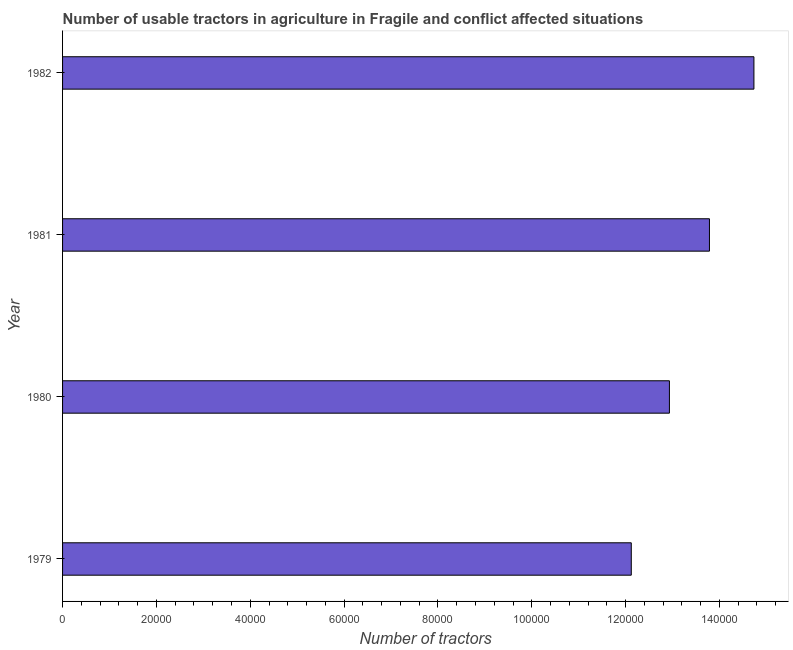Does the graph contain any zero values?
Offer a terse response. No. What is the title of the graph?
Provide a succinct answer. Number of usable tractors in agriculture in Fragile and conflict affected situations. What is the label or title of the X-axis?
Provide a succinct answer. Number of tractors. What is the number of tractors in 1980?
Make the answer very short. 1.29e+05. Across all years, what is the maximum number of tractors?
Your response must be concise. 1.47e+05. Across all years, what is the minimum number of tractors?
Offer a very short reply. 1.21e+05. In which year was the number of tractors minimum?
Keep it short and to the point. 1979. What is the sum of the number of tractors?
Give a very brief answer. 5.36e+05. What is the difference between the number of tractors in 1980 and 1982?
Offer a very short reply. -1.80e+04. What is the average number of tractors per year?
Give a very brief answer. 1.34e+05. What is the median number of tractors?
Your answer should be compact. 1.34e+05. In how many years, is the number of tractors greater than 104000 ?
Give a very brief answer. 4. Do a majority of the years between 1980 and 1981 (inclusive) have number of tractors greater than 116000 ?
Make the answer very short. Yes. What is the ratio of the number of tractors in 1981 to that in 1982?
Make the answer very short. 0.94. Is the difference between the number of tractors in 1979 and 1981 greater than the difference between any two years?
Provide a short and direct response. No. What is the difference between the highest and the second highest number of tractors?
Offer a terse response. 9479. Is the sum of the number of tractors in 1979 and 1981 greater than the maximum number of tractors across all years?
Provide a succinct answer. Yes. What is the difference between the highest and the lowest number of tractors?
Offer a very short reply. 2.61e+04. In how many years, is the number of tractors greater than the average number of tractors taken over all years?
Give a very brief answer. 2. How many bars are there?
Offer a terse response. 4. Are all the bars in the graph horizontal?
Your response must be concise. Yes. What is the Number of tractors of 1979?
Your answer should be compact. 1.21e+05. What is the Number of tractors in 1980?
Provide a succinct answer. 1.29e+05. What is the Number of tractors of 1981?
Make the answer very short. 1.38e+05. What is the Number of tractors in 1982?
Offer a terse response. 1.47e+05. What is the difference between the Number of tractors in 1979 and 1980?
Your response must be concise. -8129. What is the difference between the Number of tractors in 1979 and 1981?
Your answer should be compact. -1.67e+04. What is the difference between the Number of tractors in 1979 and 1982?
Offer a terse response. -2.61e+04. What is the difference between the Number of tractors in 1980 and 1981?
Ensure brevity in your answer.  -8530. What is the difference between the Number of tractors in 1980 and 1982?
Provide a short and direct response. -1.80e+04. What is the difference between the Number of tractors in 1981 and 1982?
Ensure brevity in your answer.  -9479. What is the ratio of the Number of tractors in 1979 to that in 1980?
Make the answer very short. 0.94. What is the ratio of the Number of tractors in 1979 to that in 1981?
Keep it short and to the point. 0.88. What is the ratio of the Number of tractors in 1979 to that in 1982?
Your answer should be compact. 0.82. What is the ratio of the Number of tractors in 1980 to that in 1981?
Ensure brevity in your answer.  0.94. What is the ratio of the Number of tractors in 1980 to that in 1982?
Make the answer very short. 0.88. What is the ratio of the Number of tractors in 1981 to that in 1982?
Give a very brief answer. 0.94. 